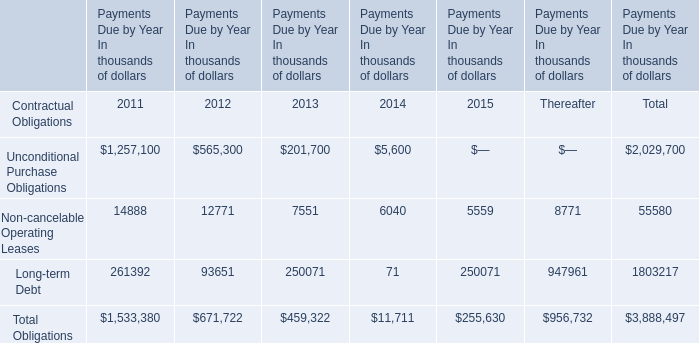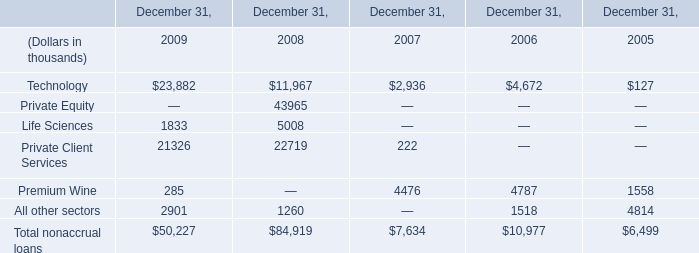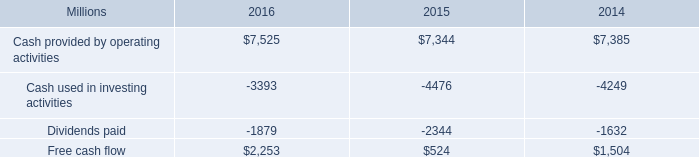what was the percentage increase in the cash provided by operating activities from 2015 to 2016 
Computations: ((7525 - 7344) / 7344)
Answer: 0.02465. 